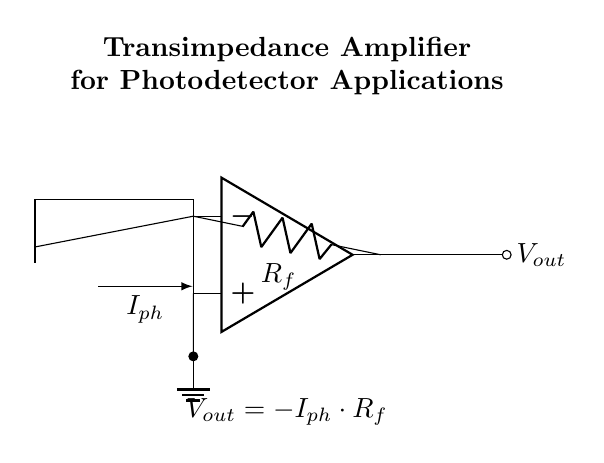What is the main component used for converting current to voltage in this circuit? The main component for conversion is the operational amplifier, which processes the input current from the photodiode to produce a corresponding output voltage.
Answer: operational amplifier What is the symbol for the input current in this circuit? The input current symbol is represented as \(I_{ph}\), which comes from the photodiode and indicates the photocurrent generated by the device.
Answer: I_{ph} What does the feedback resistor \(R_f\) do in this circuit? The feedback resistor \(R_f\) sets the gain of the transimpedance amplifier, determining the relationship between the input current and the output voltage, specifically calculating \(V_{out} = -I_{ph} \cdot R_f\).
Answer: sets the gain How does the output voltage relate to the input current? The output voltage is proportional to the negative product of the input current and the feedback resistor, given by the equation \(V_{out} = -I_{ph} \cdot R_f\).
Answer: V_{out} = -I_{ph} \cdot R_f Why is the ground connected to the non-inverting input of the op-amp? The ground is connected to the non-inverting input to provide a reference voltage, ensuring that the op-amp can correctly amplify the difference between its inverting and non-inverting inputs, which stabilizes the output.
Answer: reference voltage What is the output voltage in this circuit if the feedback resistor is 10 ohms and the photocurrent is 0.5 milliamps? First, apply the formula \(V_{out} = -I_{ph} \cdot R_f\). Converting 0.5 milliamps to amps gives \(0.0005\) A. Therefore, \(V_{out} = -0.0005 \cdot 10 = -0.005\) volts or -5 millivolts.
Answer: -5 millivolts What type of photodetector is represented in this schematic? The circuit diagram features a photodiode, indicated by the specific symbol for such devices, which converts light into an electrical current.
Answer: photodiode 